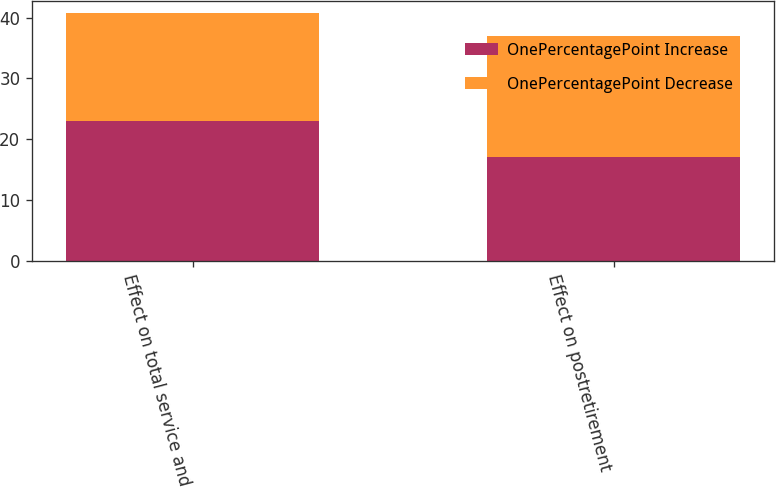<chart> <loc_0><loc_0><loc_500><loc_500><stacked_bar_chart><ecel><fcel>Effect on total service and<fcel>Effect on postretirement<nl><fcel>OnePercentagePoint Increase<fcel>23<fcel>17<nl><fcel>OnePercentagePoint Decrease<fcel>17.7<fcel>19.9<nl></chart> 